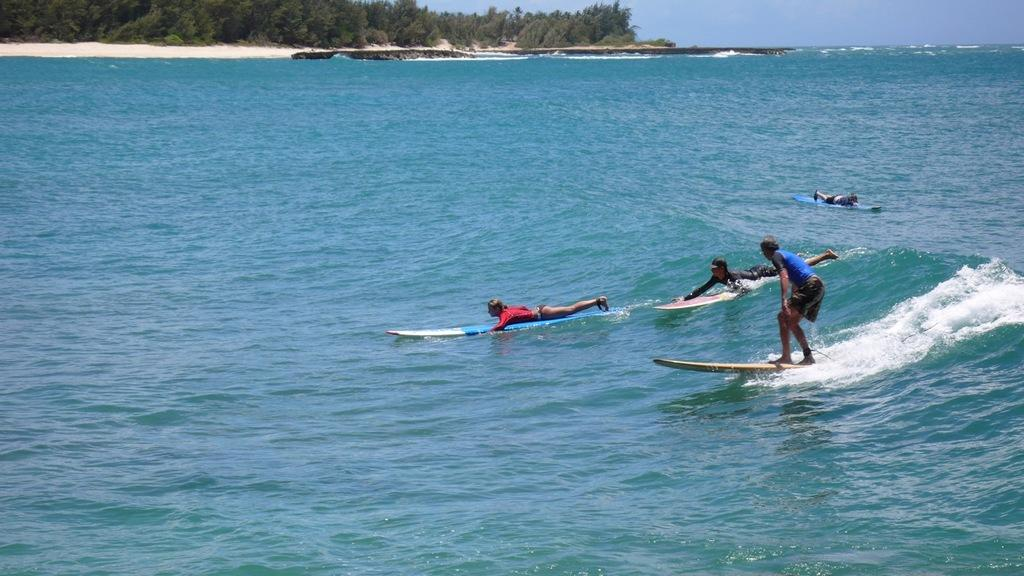What are the people in the image doing? The people in the image are surfing in the water. What can be seen in the background of the image? There is a group of trees and the sky visible at the top of the image. How many minutes does it take for the shop to increase its sales in the image? There is no shop present in the image, so it is not possible to determine how long it takes for sales to increase. 